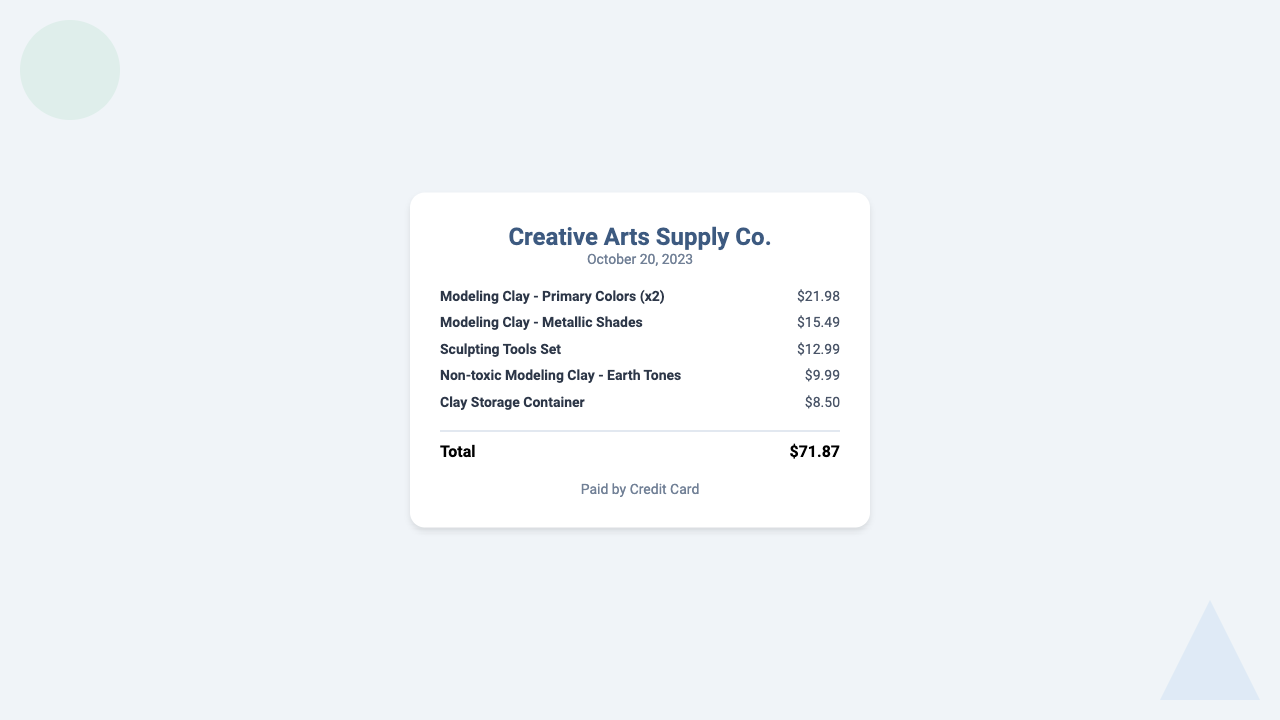What is the total amount spent? The total amount is prominently displayed at the bottom of the receipt, which sums up all item prices.
Answer: $71.87 How many types of modeling clay were purchased? The receipt lists multiple types of modeling clay, which can be counted from the items section.
Answer: 3 What date was the purchase made? The date of purchase is shown at the top of the receipt under the header section.
Answer: October 20, 2023 What is the price of the sculpting tools set? The price for the sculpting tools set is specified next to its name in the items list.
Answer: $12.99 Which item has the lowest price? The prices of all items are listed, and comparing them will reveal the one with the lowest cost.
Answer: Clay Storage Container What payment method was used? This information is provided in the payment section at the bottom of the receipt.
Answer: Credit Card How many modeling clay items were purchased in total? The total number of modeling clay items can be determined by counting the quantity listed for each type in the items section.
Answer: 3 What is the price of the metallic shades modeling clay? The price is indicated next to the item name in the receipt.
Answer: $15.49 